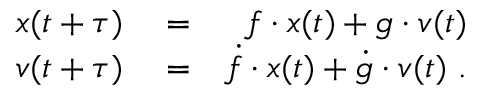<formula> <loc_0><loc_0><loc_500><loc_500>\begin{array} { r l r } { \ v { x } ( t + \tau ) } & = } & { f \cdot \ v { x } ( t ) + g \cdot \ v { v } ( t ) } \\ { \ v { v } ( t + \tau ) } & = } & { \dot { f } \cdot \ v { x } ( t ) + \dot { g } \cdot \ v { v } ( t ) \ . } \end{array}</formula> 